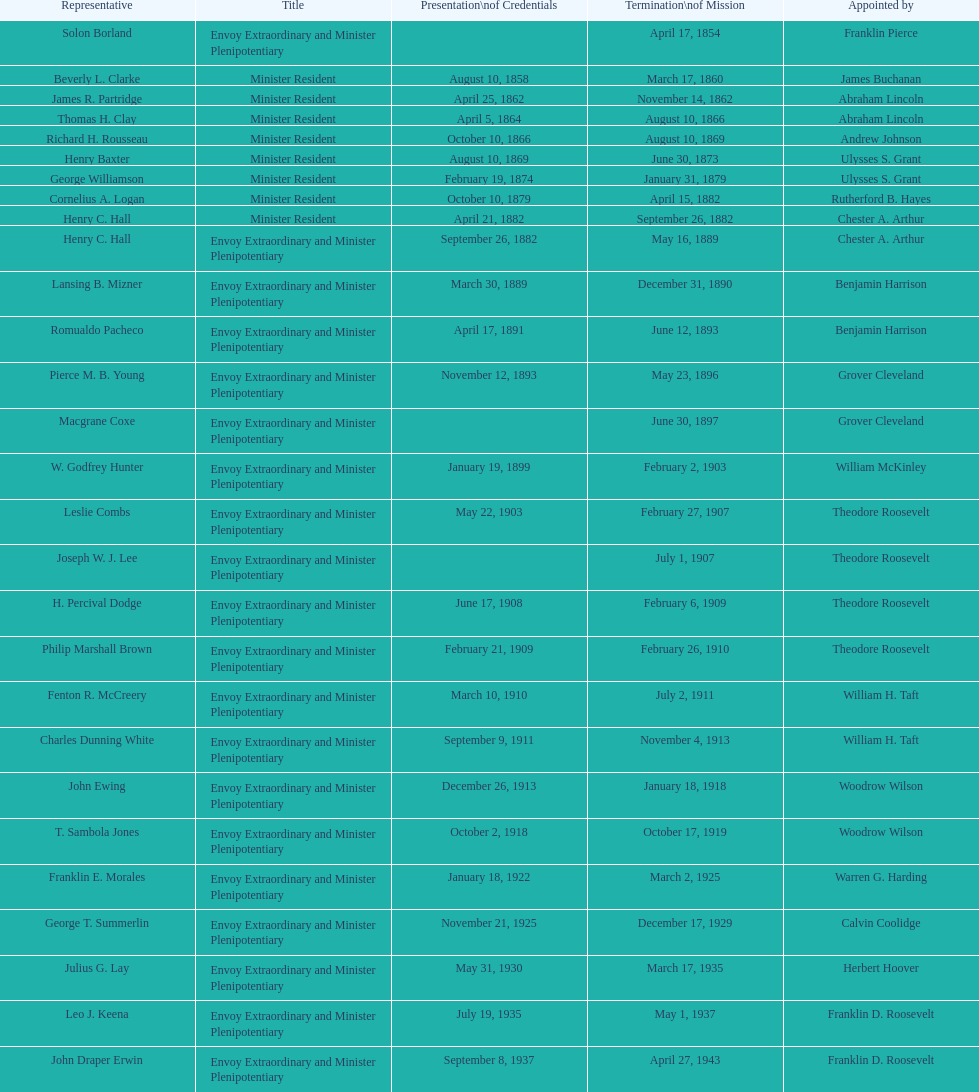How many representatives were assigned by theodore roosevelt? 4. 